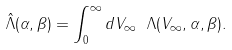Convert formula to latex. <formula><loc_0><loc_0><loc_500><loc_500>\hat { \Lambda } ( \alpha , \beta ) = \int _ { 0 } ^ { \infty } d V _ { \infty } \ \Lambda ( { V _ { \infty } } , \alpha , \beta ) .</formula> 